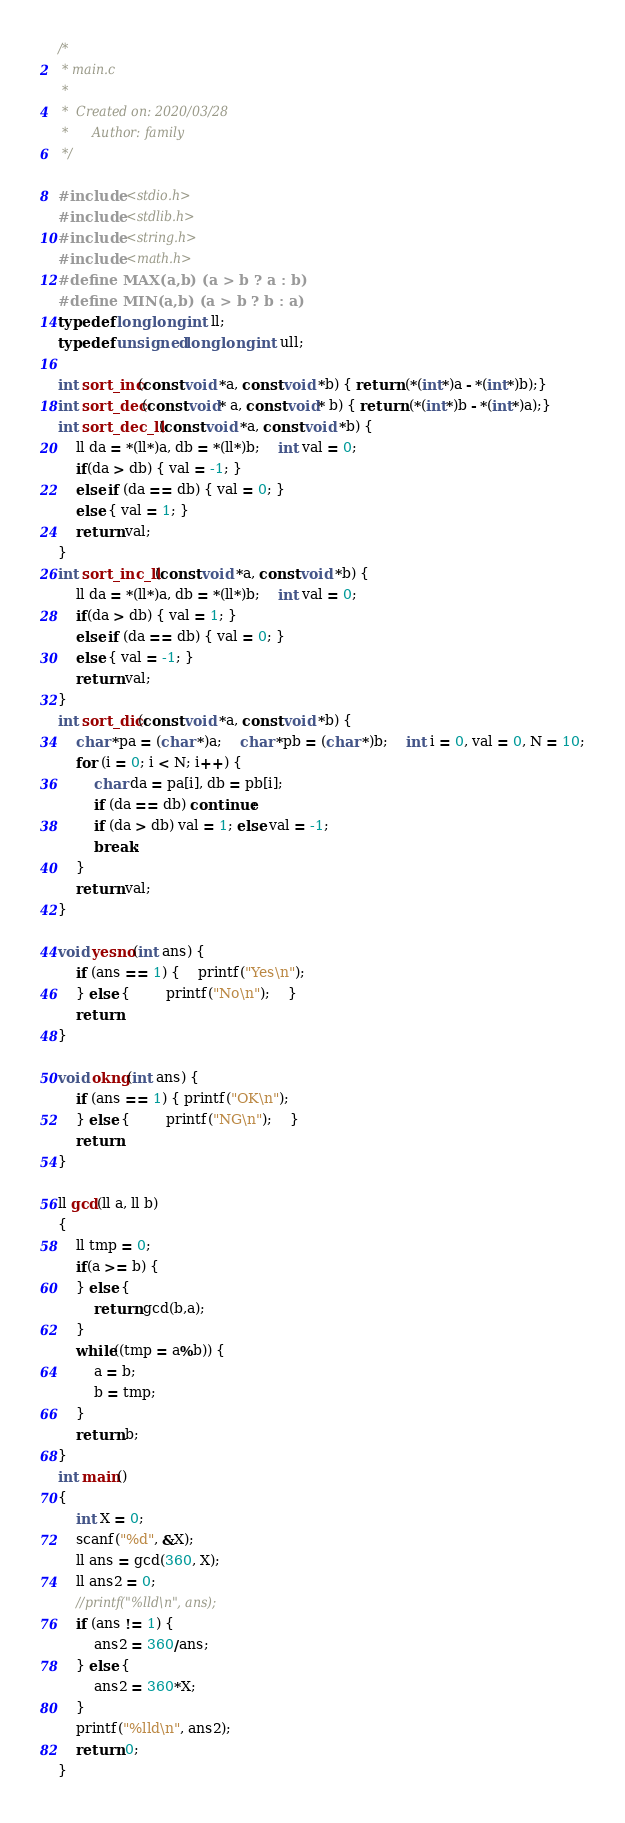<code> <loc_0><loc_0><loc_500><loc_500><_C_>/*
 * main.c
 *
 *  Created on: 2020/03/28
 *      Author: family
 */

#include <stdio.h>
#include <stdlib.h>
#include <string.h>
#include <math.h>
#define MAX(a,b) (a > b ? a : b)
#define MIN(a,b) (a > b ? b : a)
typedef long long int ll;
typedef unsigned long long int ull;

int sort_inc(const void *a, const void *b) { return (*(int*)a - *(int*)b);}
int sort_dec(const void* a, const void* b) { return (*(int*)b - *(int*)a);}
int sort_dec_ll(const void *a, const void *b) {
    ll da = *(ll*)a, db = *(ll*)b;    int val = 0;
    if(da > db) { val = -1; }
    else if (da == db) { val = 0; }
    else { val = 1; }
    return val;
}
int sort_inc_ll(const void *a, const void *b) {
    ll da = *(ll*)a, db = *(ll*)b;    int val = 0;
    if(da > db) { val = 1; }
    else if (da == db) { val = 0; }
    else { val = -1; }
    return val;
}
int sort_dic(const void *a, const void *b) {
    char *pa = (char *)a;    char *pb = (char *)b;    int i = 0, val = 0, N = 10;
    for (i = 0; i < N; i++) {
    	char da = pa[i], db = pb[i];
    	if (da == db) continue;
  		if (da > db) val = 1; else val = -1;
        break;
    }
    return val;
}

void yesno(int ans) {
	if (ans == 1) {	printf("Yes\n");
	} else {		printf("No\n");	}
	return;
}

void okng(int ans) {
	if (ans == 1) { printf("OK\n");
	} else { 		printf("NG\n");	}
	return;
}

ll gcd(ll a, ll b)
{
	ll tmp = 0;
	if(a >= b) {
	} else {
		return gcd(b,a);
	}
	while((tmp = a%b)) {
		a = b;
		b = tmp;
	}
	return b;
}
int main()
{
	int X = 0;
	scanf("%d", &X);
	ll ans = gcd(360, X);
	ll ans2 = 0;
	//printf("%lld\n", ans);
	if (ans != 1) {
		ans2 = 360/ans;
	} else {
		ans2 = 360*X;
	}
	printf("%lld\n", ans2);
	return 0;
}
</code> 